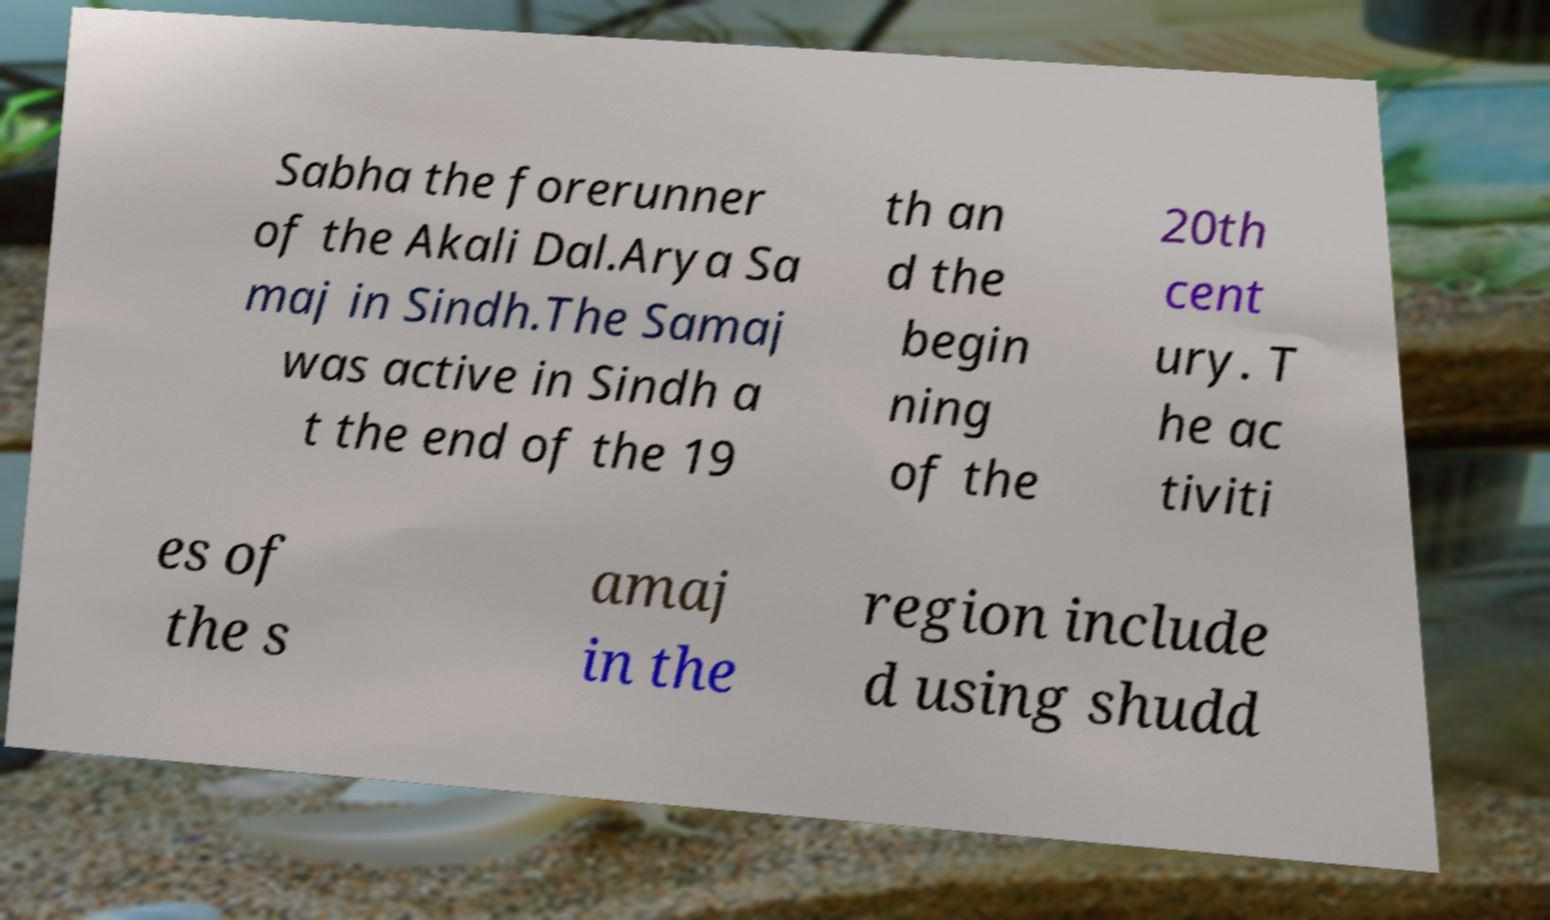I need the written content from this picture converted into text. Can you do that? Sabha the forerunner of the Akali Dal.Arya Sa maj in Sindh.The Samaj was active in Sindh a t the end of the 19 th an d the begin ning of the 20th cent ury. T he ac tiviti es of the s amaj in the region include d using shudd 